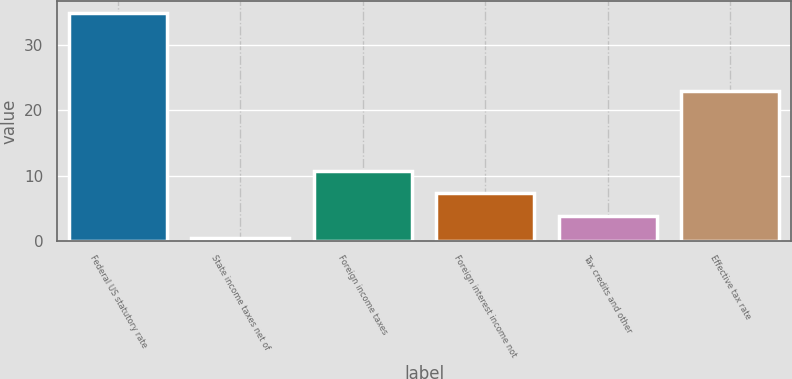Convert chart to OTSL. <chart><loc_0><loc_0><loc_500><loc_500><bar_chart><fcel>Federal US statutory rate<fcel>State income taxes net of<fcel>Foreign income taxes<fcel>Foreign interest income not<fcel>Tax credits and other<fcel>Effective tax rate<nl><fcel>35<fcel>0.4<fcel>10.78<fcel>7.32<fcel>3.86<fcel>23.06<nl></chart> 